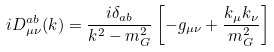Convert formula to latex. <formula><loc_0><loc_0><loc_500><loc_500>i D ^ { a b } _ { \mu \nu } ( k ) = \frac { i \delta _ { a b } } { k ^ { 2 } - m ^ { 2 } _ { G } } \left [ - g _ { \mu \nu } + \frac { k _ { \mu } k _ { \nu } } { m ^ { 2 } _ { G } } \right ]</formula> 